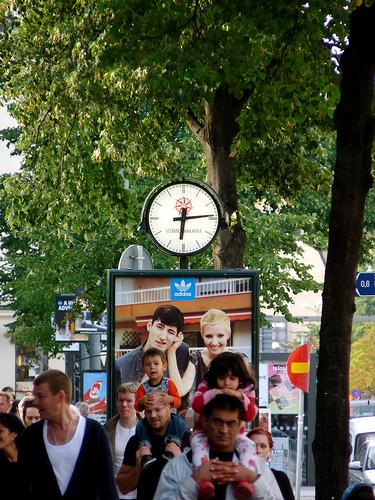Question: why are they smiling?
Choices:
A. They are happy.
B. For a picture.
C. There is a ball.
D. They like the gift.
Answer with the letter. Answer: B Question: who is sitting on shoulders?
Choices:
A. Little boy.
B. Baby.
C. Little girl.
D. Child.
Answer with the letter. Answer: D Question: where is the clock?
Choices:
A. On the building.
B. On the wall.
C. On the table.
D. Above the people.
Answer with the letter. Answer: D Question: what is red?
Choices:
A. The firetruck.
B. The fire.
C. Shoes.
D. The house.
Answer with the letter. Answer: C Question: how many clocks?
Choices:
A. 2.
B. 3.
C. 1.
D. 4.
Answer with the letter. Answer: C 